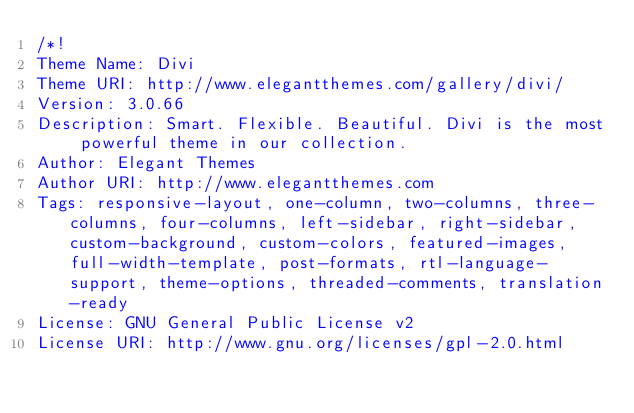<code> <loc_0><loc_0><loc_500><loc_500><_CSS_>/*!
Theme Name: Divi
Theme URI: http://www.elegantthemes.com/gallery/divi/
Version: 3.0.66
Description: Smart. Flexible. Beautiful. Divi is the most powerful theme in our collection.
Author: Elegant Themes
Author URI: http://www.elegantthemes.com
Tags: responsive-layout, one-column, two-columns, three-columns, four-columns, left-sidebar, right-sidebar, custom-background, custom-colors, featured-images, full-width-template, post-formats, rtl-language-support, theme-options, threaded-comments, translation-ready
License: GNU General Public License v2
License URI: http://www.gnu.org/licenses/gpl-2.0.html</code> 